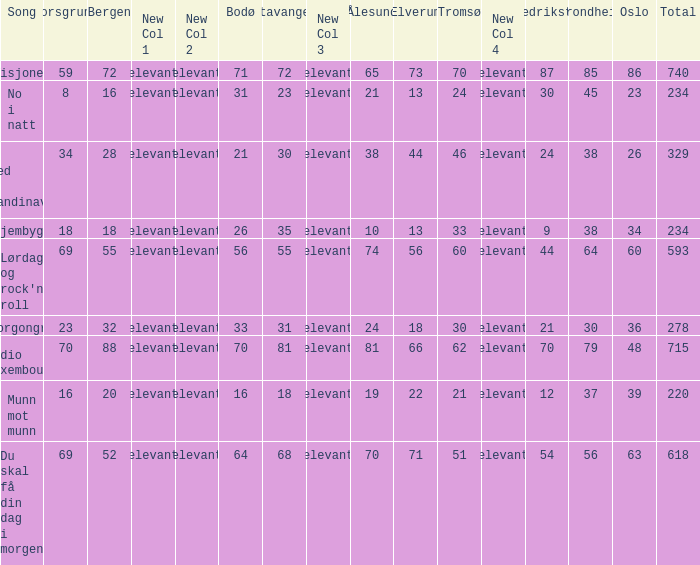When bergen is 88, what is the alesund? 81.0. 